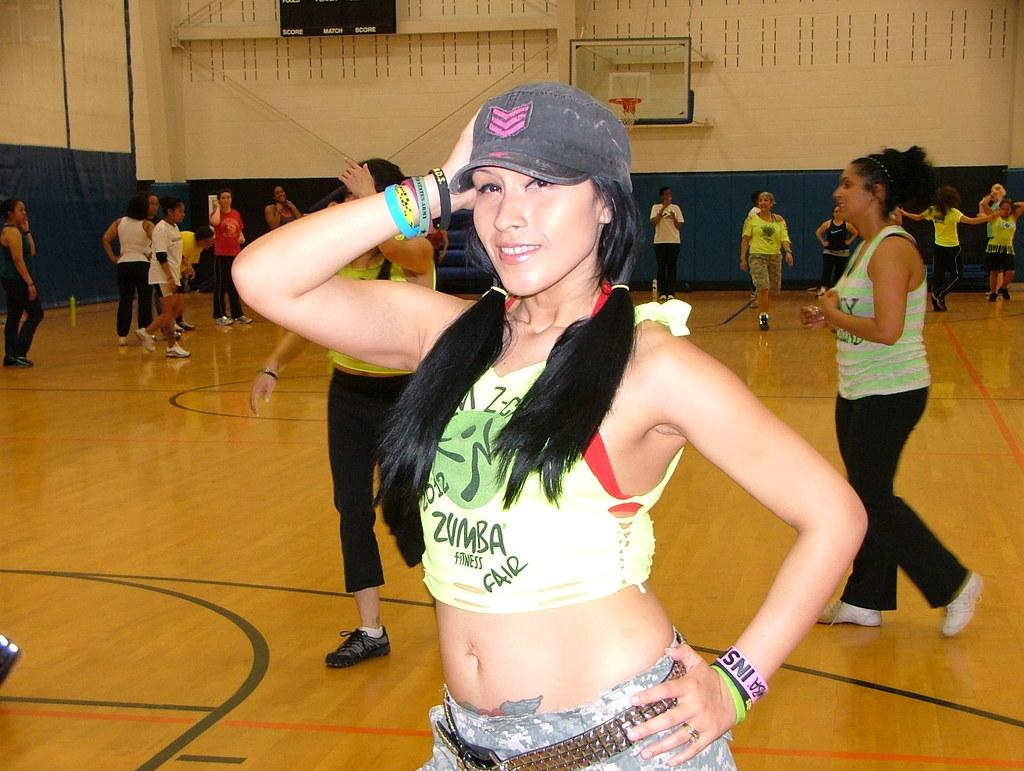Who is the main subject in the image? There is a lady in the image. What is the lady wearing on her head? The lady is wearing a cap. What other accessories is the lady wearing? The lady is wearing wristbands. What can be seen in the background of the image? There are many people and a wall in the background of the image. What is on the wall in the background? There is a board with a basketball net on the wall. What type of coat is the lady wearing in the image? The lady is not wearing a coat in the image; she is wearing a cap and wristbands. How many tickets can be seen in the lady's hand in the image? There are no tickets visible in the lady's hand in the image. 